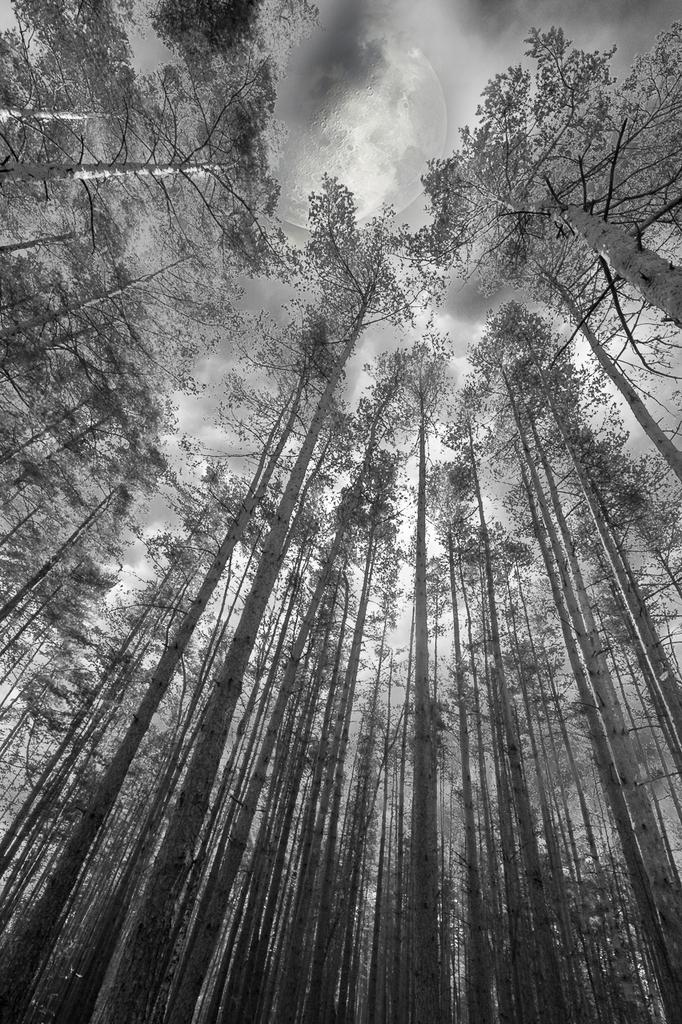What type of vegetation can be seen in the image? There are trees in the image. What part of the natural environment is visible in the image? The sky is visible in the background of the image. What type of gun can be heard in the image? There is no gun or sound present in the image; it only features trees and the sky. What type of nut is growing on the trees in the image? There is no information about nuts or any specific type of tree in the image, so it cannot be determined. 